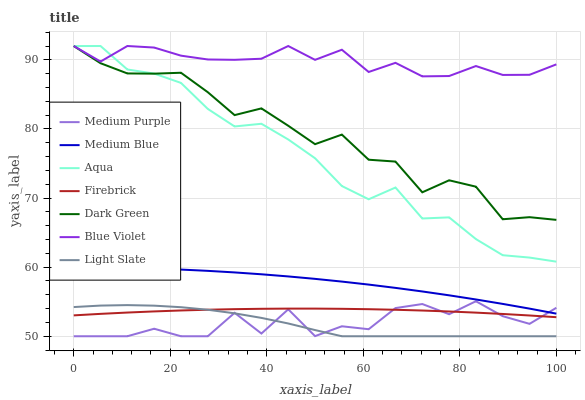Does Medium Blue have the minimum area under the curve?
Answer yes or no. No. Does Medium Blue have the maximum area under the curve?
Answer yes or no. No. Is Medium Blue the smoothest?
Answer yes or no. No. Is Medium Blue the roughest?
Answer yes or no. No. Does Medium Blue have the lowest value?
Answer yes or no. No. Does Medium Blue have the highest value?
Answer yes or no. No. Is Firebrick less than Aqua?
Answer yes or no. Yes. Is Dark Green greater than Firebrick?
Answer yes or no. Yes. Does Firebrick intersect Aqua?
Answer yes or no. No. 